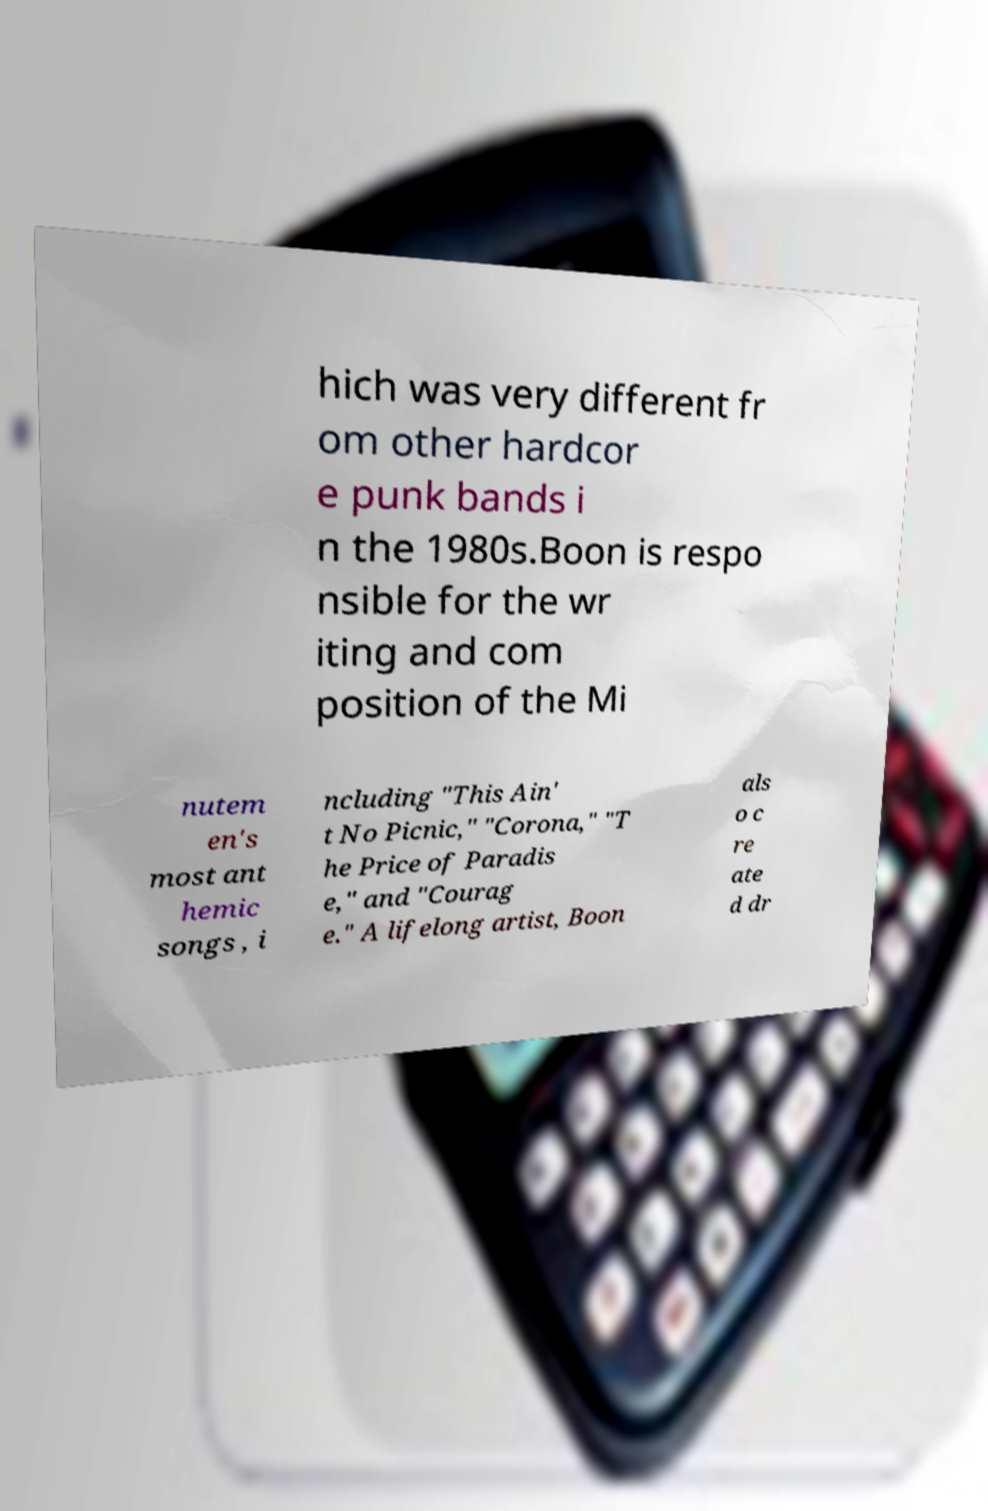There's text embedded in this image that I need extracted. Can you transcribe it verbatim? hich was very different fr om other hardcor e punk bands i n the 1980s.Boon is respo nsible for the wr iting and com position of the Mi nutem en's most ant hemic songs , i ncluding "This Ain' t No Picnic," "Corona," "T he Price of Paradis e," and "Courag e." A lifelong artist, Boon als o c re ate d dr 